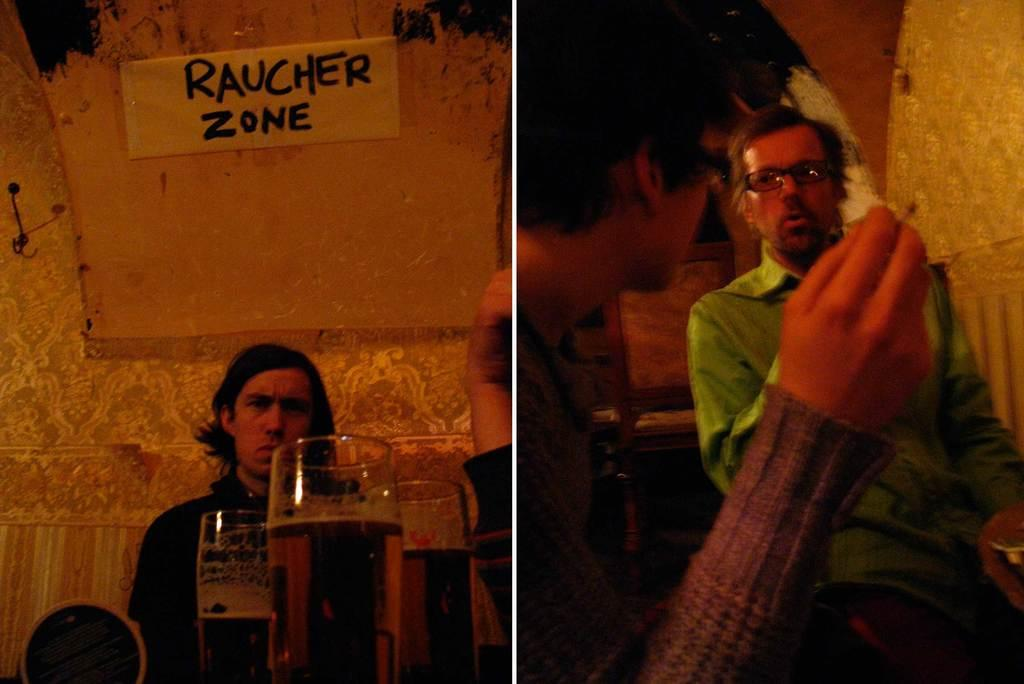<image>
Share a concise interpretation of the image provided. A man sits under a hand-written sign that says rauncher zone. 